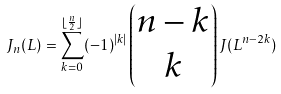Convert formula to latex. <formula><loc_0><loc_0><loc_500><loc_500>J _ { n } ( L ) = \sum _ { { k } = { 0 } } ^ { \lfloor \frac { n } { 2 } \rfloor } ( - 1 ) ^ { | k | } \begin{pmatrix} { n } - { k } \\ { k } \end{pmatrix} J ( L ^ { { n } - 2 { k } } )</formula> 